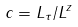Convert formula to latex. <formula><loc_0><loc_0><loc_500><loc_500>c = L _ { \tau } / L ^ { z }</formula> 